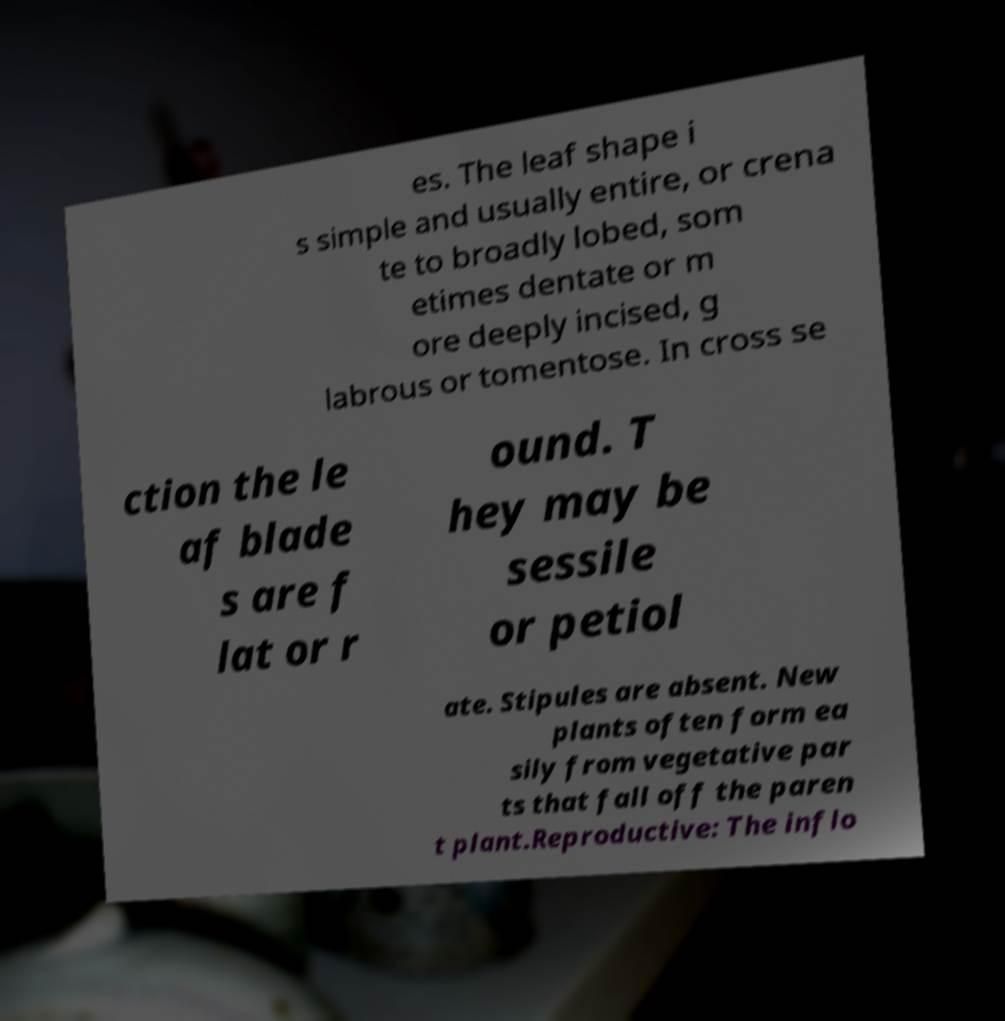Could you assist in decoding the text presented in this image and type it out clearly? es. The leaf shape i s simple and usually entire, or crena te to broadly lobed, som etimes dentate or m ore deeply incised, g labrous or tomentose. In cross se ction the le af blade s are f lat or r ound. T hey may be sessile or petiol ate. Stipules are absent. New plants often form ea sily from vegetative par ts that fall off the paren t plant.Reproductive: The inflo 